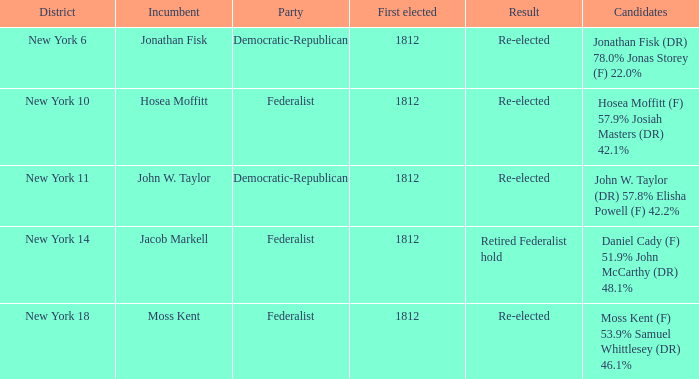Name the incumbent for new york 10 Hosea Moffitt. 